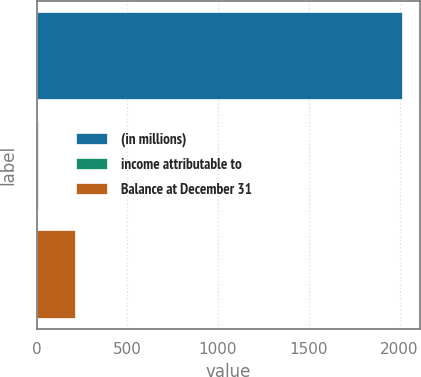<chart> <loc_0><loc_0><loc_500><loc_500><bar_chart><fcel>(in millions)<fcel>income attributable to<fcel>Balance at December 31<nl><fcel>2012<fcel>10.5<fcel>210.65<nl></chart> 